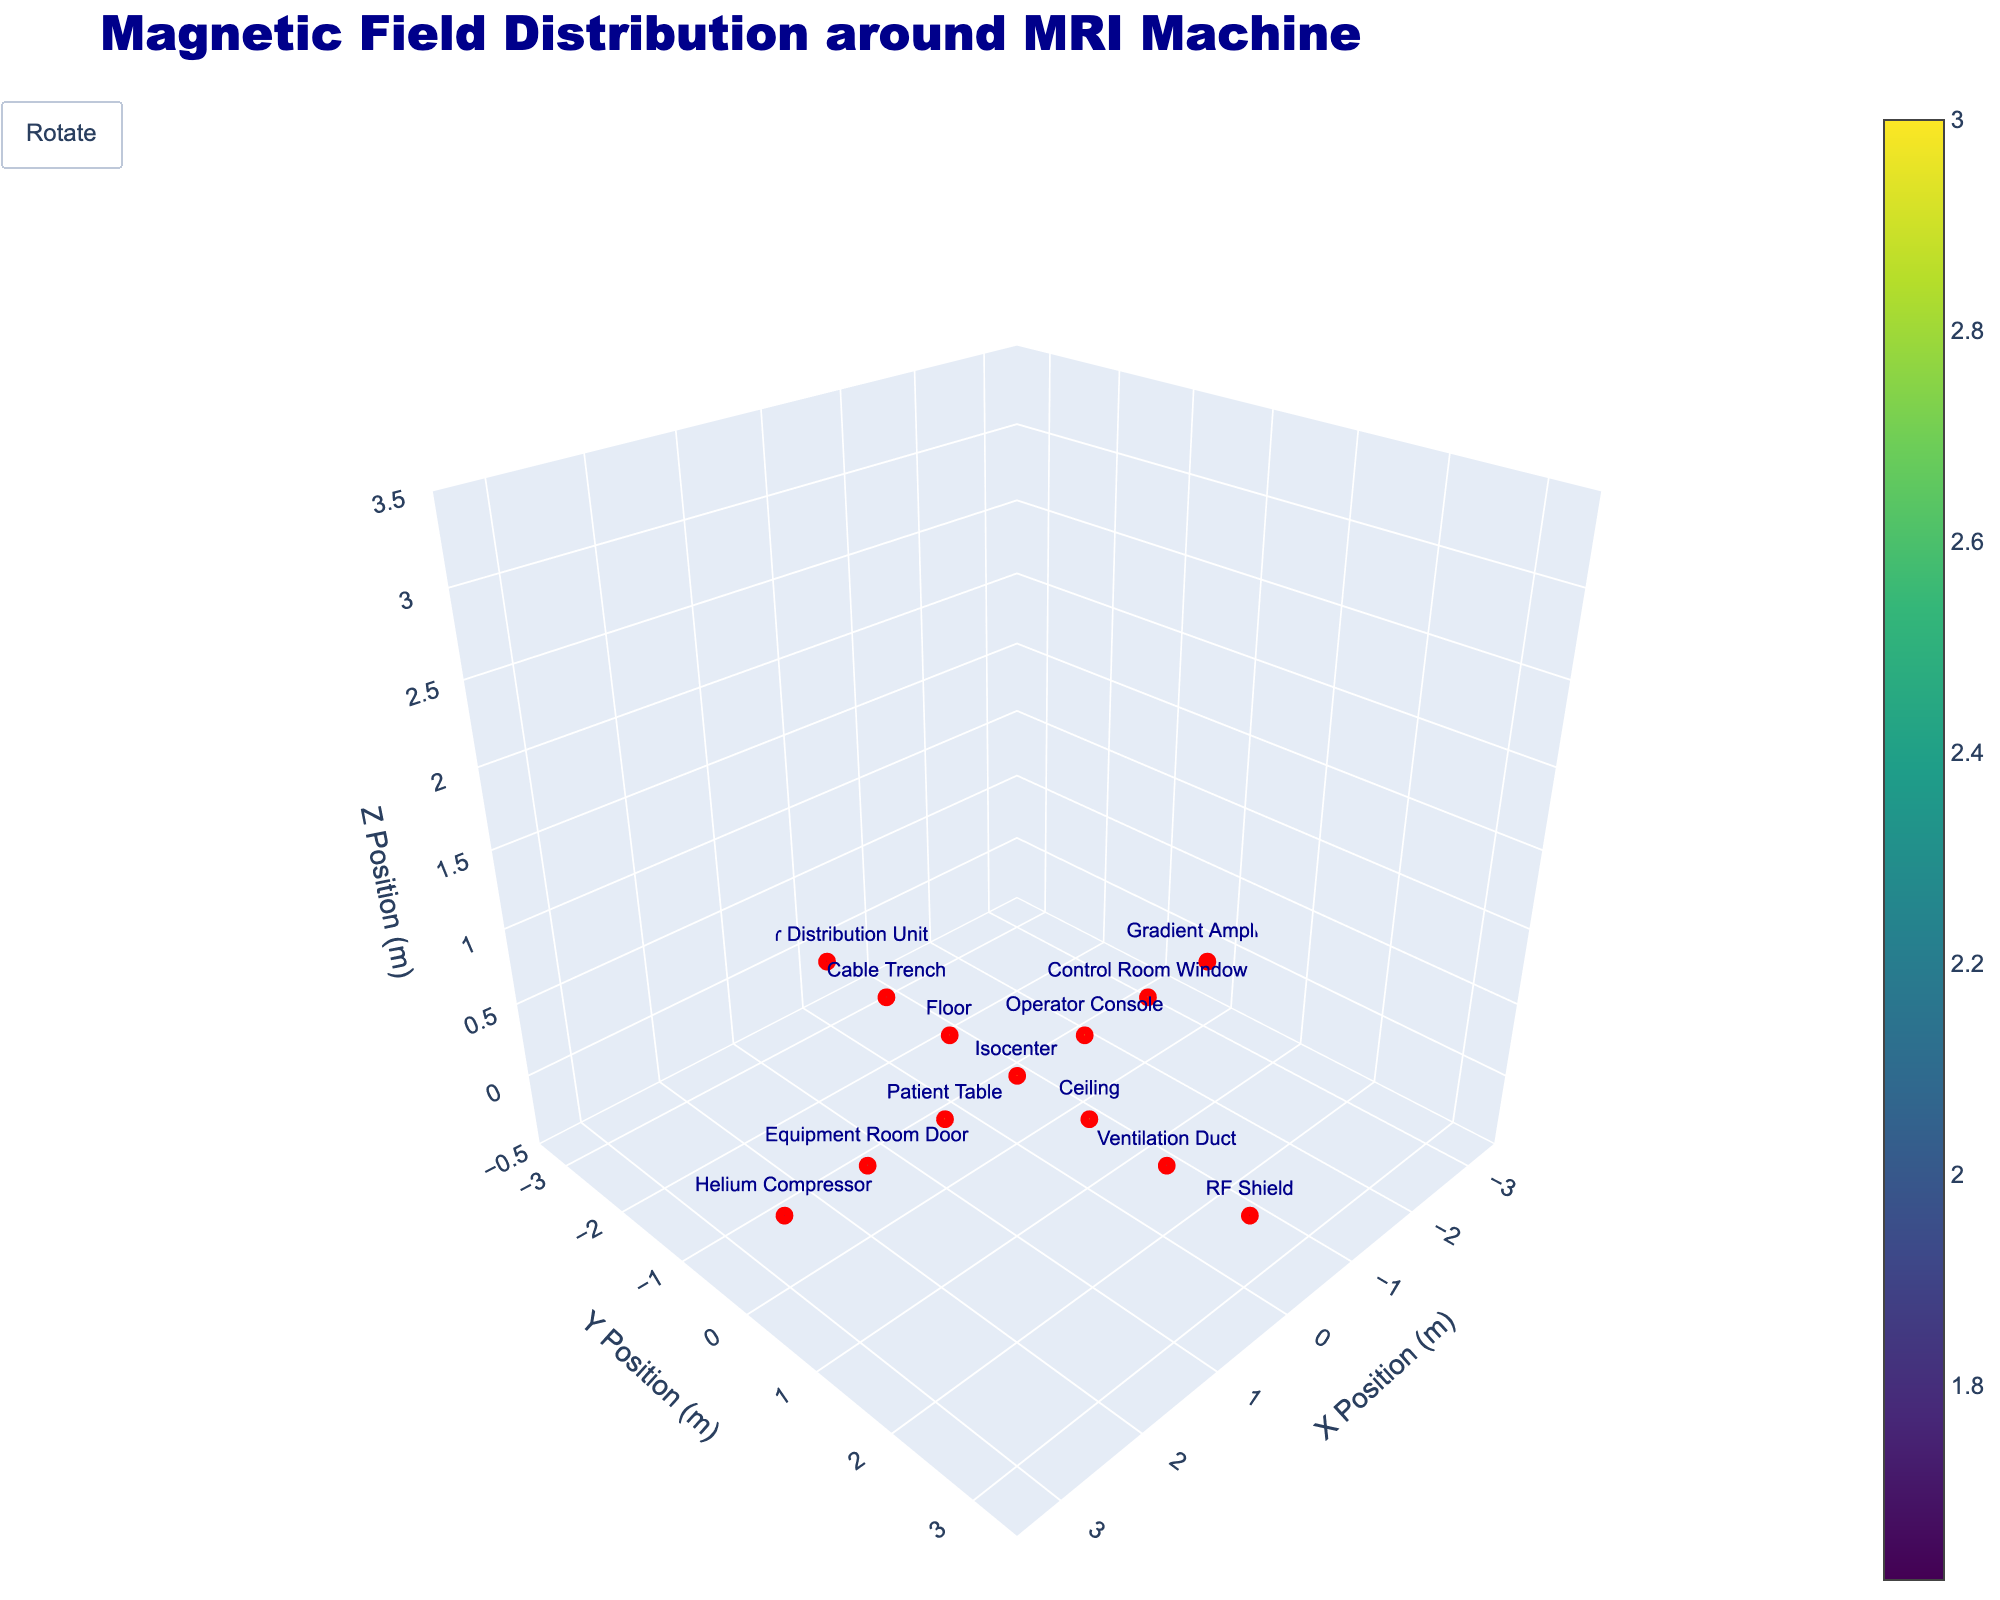What is the title of the plot? The title can be found at the upper part of the figure, typically with larger font size and different style compared to other text elements. The title is “Magnetic Field Distribution around MRI Machine”.
Answer: Magnetic Field Distribution around MRI Machine Which data point has the highest magnetic field strength in the Z direction (Bz)? To determine this, compare the Bz values of each data point. The Helium Compressor and Gradient Amplifier both have the highest Bz at 1.8.
Answer: Helium Compressor, Gradient Amplifier Where do we observe the magnetic field vector (Bx, By, Bz) of (0.3, 0, 2.5)? The plot has markers showing locations with text labels. Identify the point with a vector of (0.3, 0, 2.5) which is labeled as Equipment Room Door.
Answer: Equipment Room Door Which location is directly above the isocenter along the Y-axis? Look for a data point that is positioned in the positive Y-axis direction from the isocenter with no X-axis displacement. That point is on the Ceiling with coordinates (0,1,0).
Answer: Ceiling How many locations have a Bz value less than 2.0? Check each data point's Bz value and count those below 2.0. The locations that meet this criterion are Helium Compressor, Gradient Amplifier, RF Shield, and Power Distribution Unit, totaling 4 locations.
Answer: 4 What is the average Bx value across all locations? Sum up all Bx values: 0 (Isocenter) + 0.1 (Patient Table) + (-0.1) (Operator Console) + 0 (Ceiling) + 0 (Floor) + 0.3 (Equipment Room Door) + (-0.3) (Control Room Window) + 0 (Ventilation Duct) + 0 (Cable Trench) + 0.5 (Helium Compressor) + (-0.5) (Gradient Amplifier) + 0 (RF Shield) + 0 (Power Distribution Unit) = 0. Then divide by 13 (number of locations) = 0.
Answer: 0 Between the Ceiling and Floor, which has a stronger magnetic field in the Y direction (By)? Compare the By values of the Ceiling and the Floor. The Ceiling's By is 0.2 and the Floor's By is -0.2.
Answer: They have equal magnitude Which locations show magnetic field vectors pointing purely along one primary axis (X, Y, or Z)? Examine each vector and identify those with non-zero components only in one direction. These locations include Operator Console (-0.1,0,2.9), Ceiling (0,0.2,2.8), Floor (0,-0.2,2.8), Equipment Room Door (0.3,0,2.5), Control Room Window (-0.3,0,2.5), Helium Compressor (0.5,0,1.8), Gradient Amplifier (-0.5,0,1.8), RF Shield (0,0.6,1.5), and Power Distribution Unit (0,-0.6,1.5).
Answer: Operator Console, Ceiling, Floor, Equipment Room Door, Control Room Window, Helium Compressor, Gradient Amplifier, RF Shield, Power Distribution Unit What is the range of magnetic field strength in the Z direction (Bz) for all locations? Identify the min and max Bz values from the data points: The minimum Bz is 1.5 (RF Shield, Power Distribution Unit) and the maximum Bz is 3 (Isocenter). The range is 3 - 1.5 = 1.5.
Answer: 1.5 